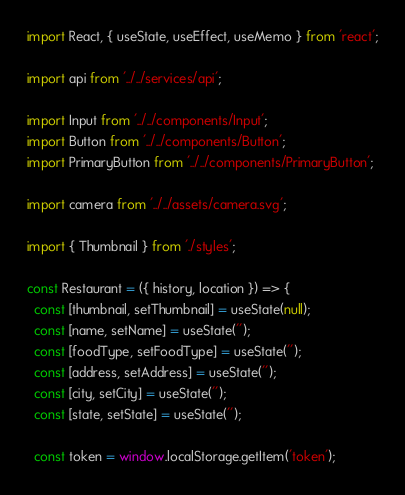Convert code to text. <code><loc_0><loc_0><loc_500><loc_500><_JavaScript_>import React, { useState, useEffect, useMemo } from 'react';

import api from '../../services/api';

import Input from '../../components/Input';
import Button from '../../components/Button';
import PrimaryButton from '../../components/PrimaryButton';

import camera from '../../assets/camera.svg';

import { Thumbnail } from './styles';

const Restaurant = ({ history, location }) => {
  const [thumbnail, setThumbnail] = useState(null);
  const [name, setName] = useState('');
  const [foodType, setFoodType] = useState('');
  const [address, setAddress] = useState('');
  const [city, setCity] = useState('');
  const [state, setState] = useState('');

  const token = window.localStorage.getItem('token');</code> 